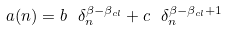Convert formula to latex. <formula><loc_0><loc_0><loc_500><loc_500>a ( n ) = b \ \delta _ { n } ^ { \beta - \beta _ { c l } } + c \ \delta _ { n } ^ { \beta - \beta _ { c l } + 1 }</formula> 